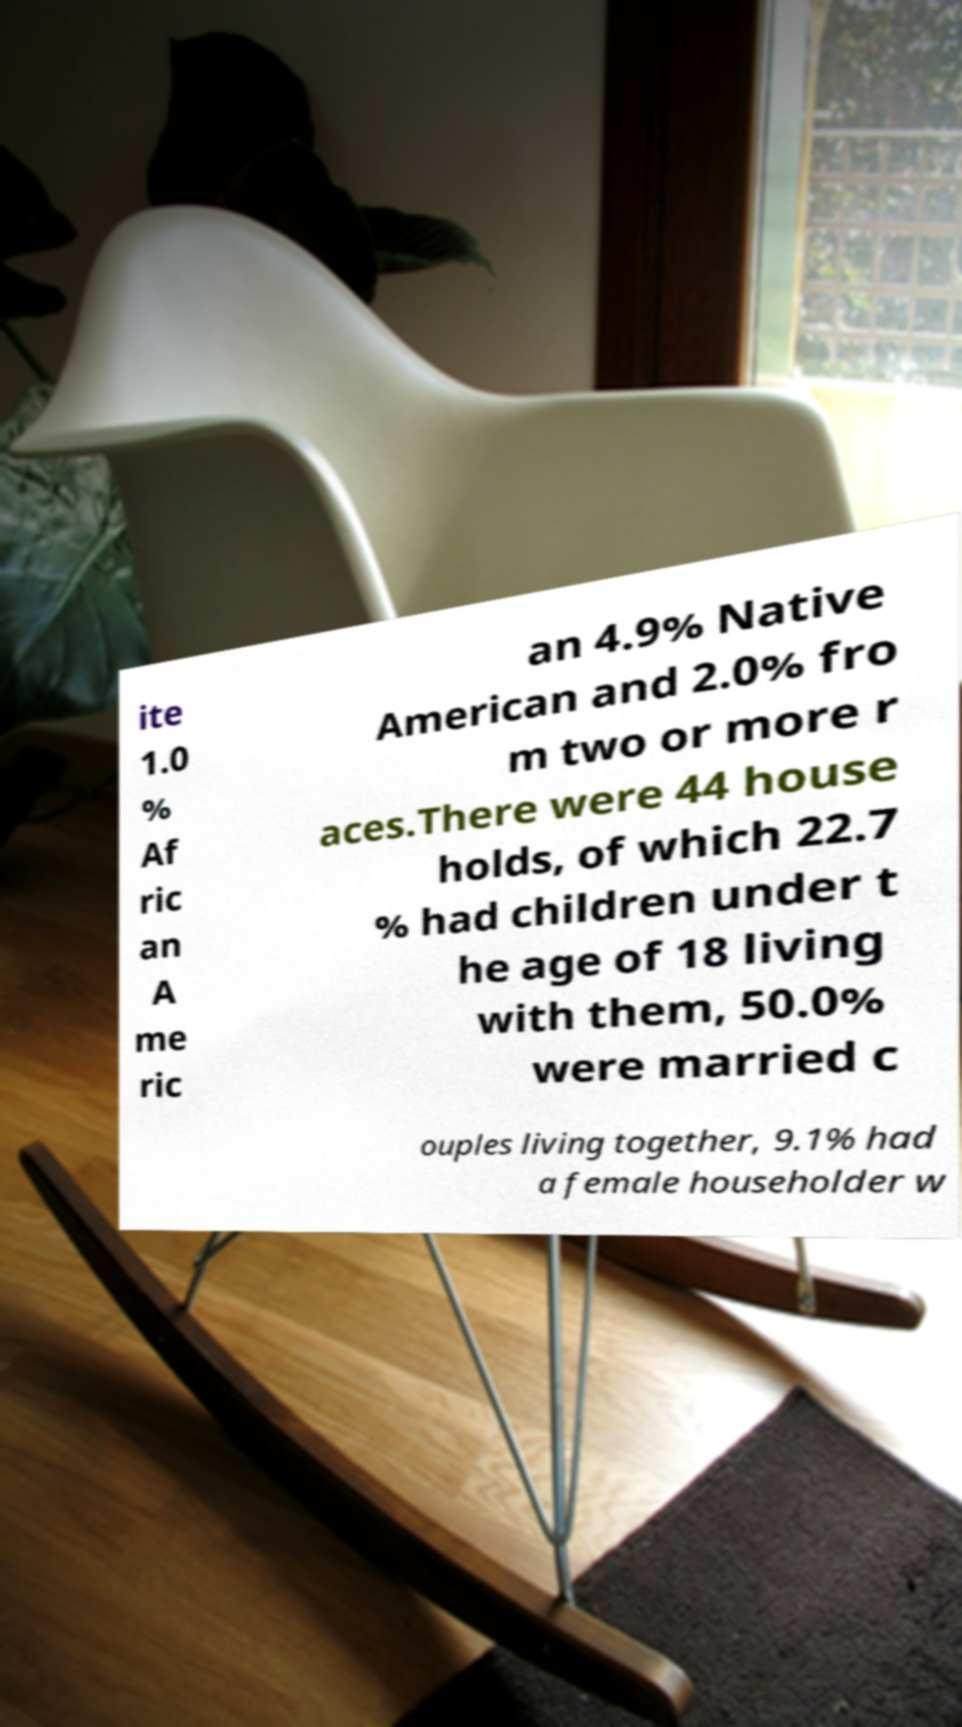Can you accurately transcribe the text from the provided image for me? ite 1.0 % Af ric an A me ric an 4.9% Native American and 2.0% fro m two or more r aces.There were 44 house holds, of which 22.7 % had children under t he age of 18 living with them, 50.0% were married c ouples living together, 9.1% had a female householder w 